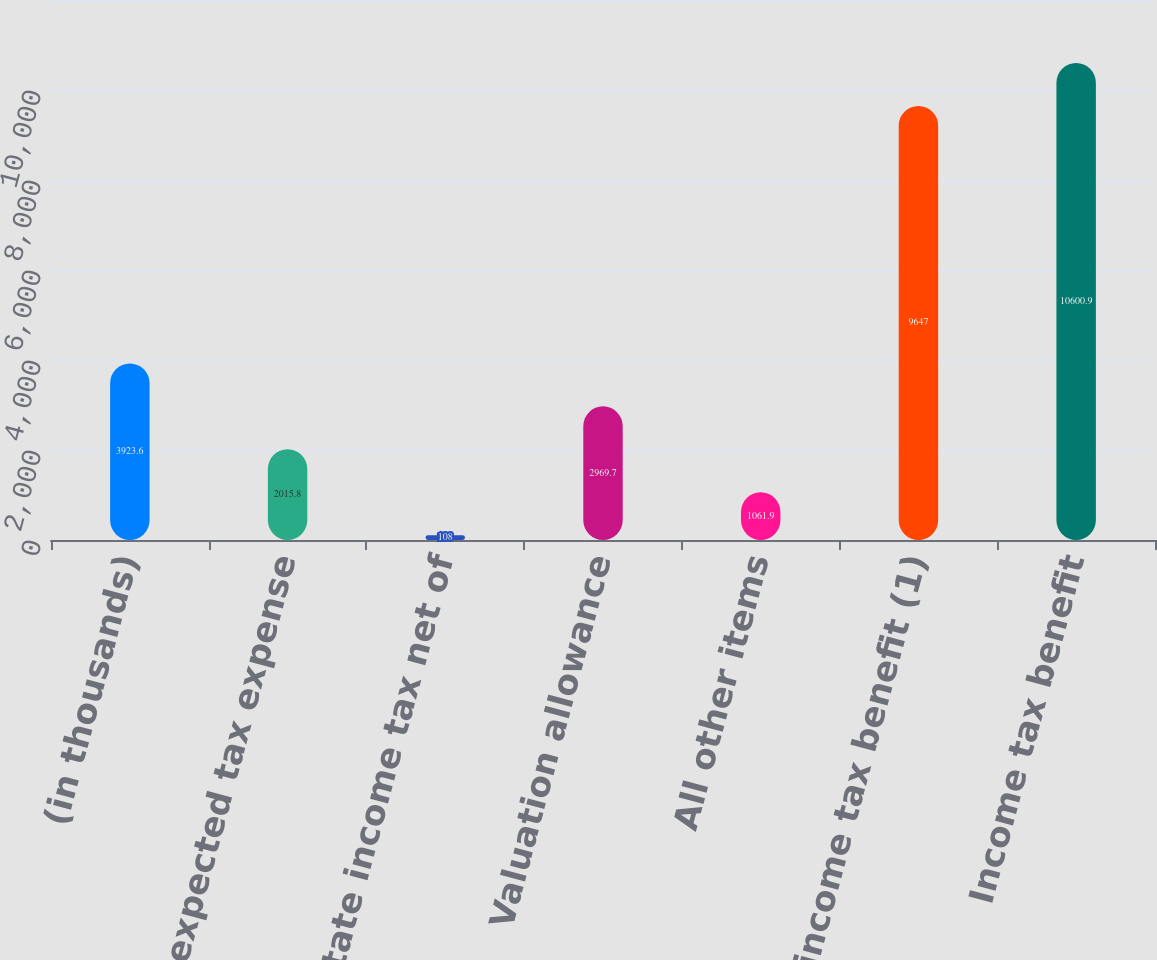<chart> <loc_0><loc_0><loc_500><loc_500><bar_chart><fcel>(in thousands)<fcel>Computed expected tax expense<fcel>State income tax net of<fcel>Valuation allowance<fcel>All other items<fcel>Total income tax benefit (1)<fcel>Income tax benefit<nl><fcel>3923.6<fcel>2015.8<fcel>108<fcel>2969.7<fcel>1061.9<fcel>9647<fcel>10600.9<nl></chart> 